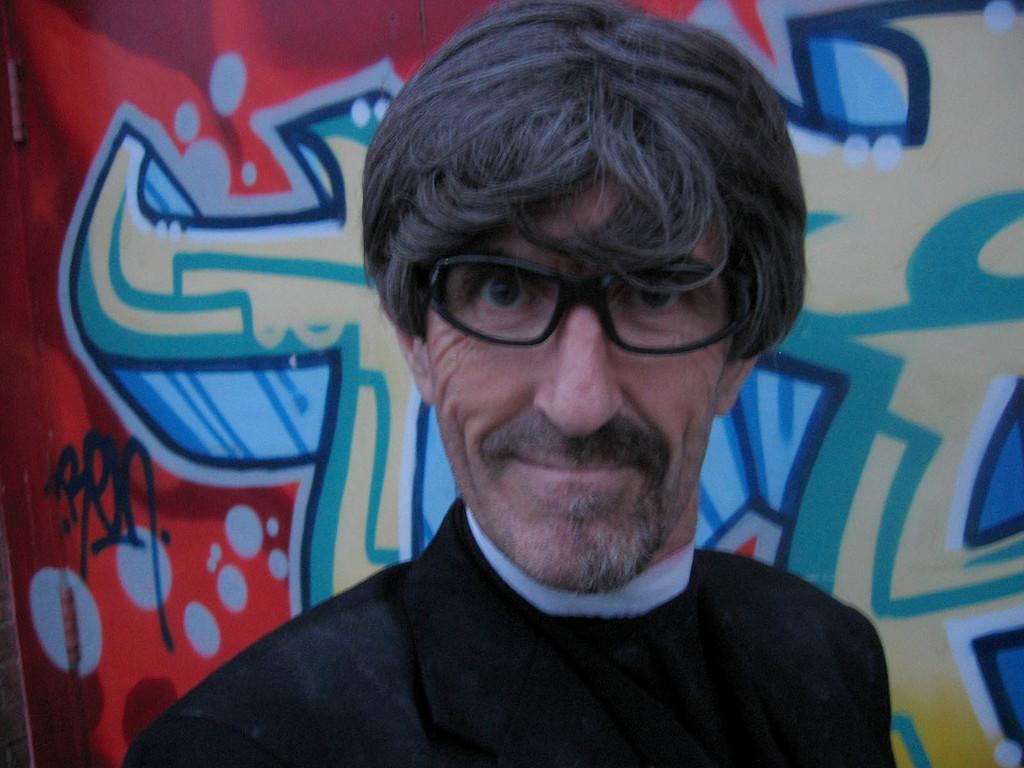Can you describe this image briefly? In this picture there is a person wearing black suit and there is a wall which has a painting on it behind him. 